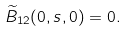<formula> <loc_0><loc_0><loc_500><loc_500>\widetilde { B } _ { 1 2 } ( 0 , s , 0 ) = 0 .</formula> 